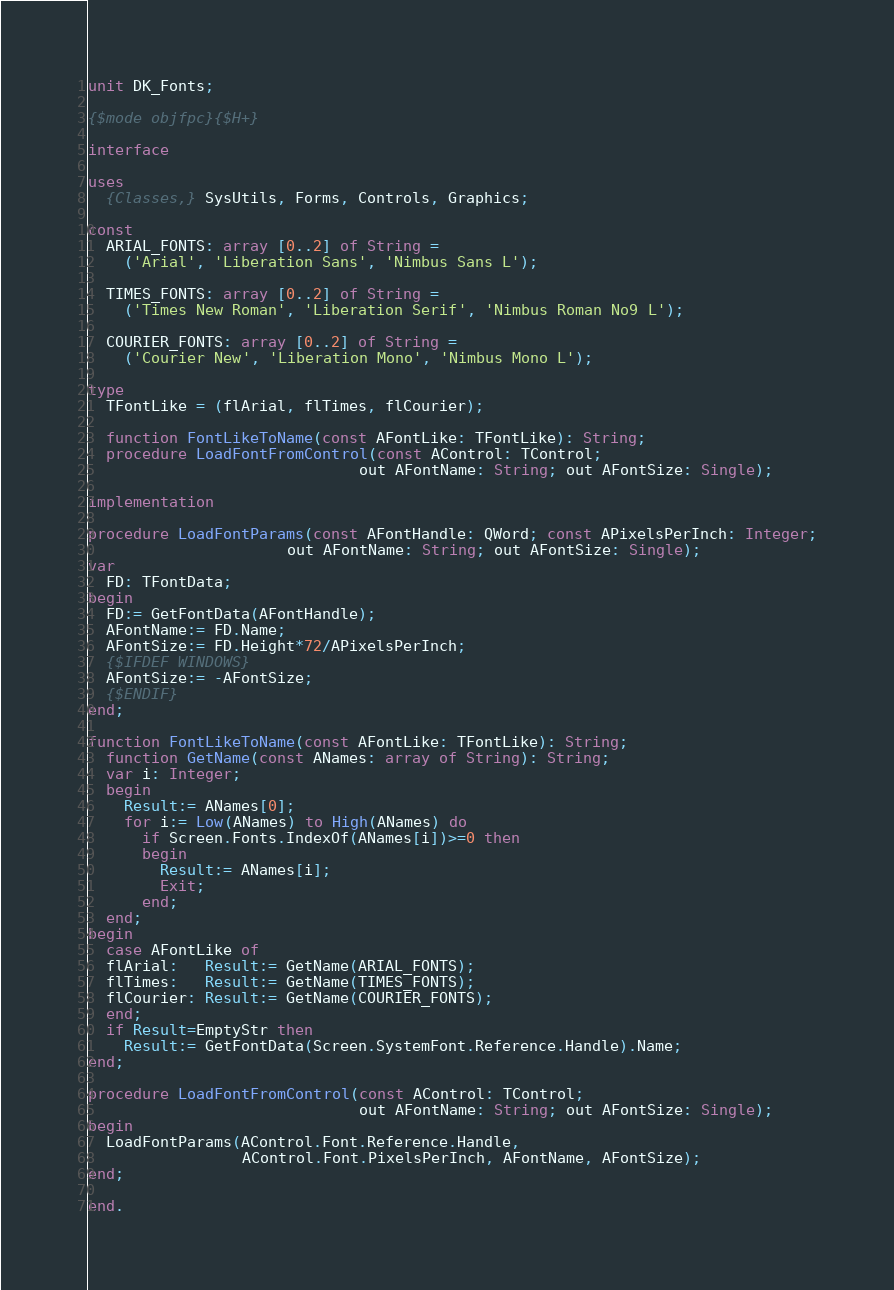Convert code to text. <code><loc_0><loc_0><loc_500><loc_500><_Pascal_>unit DK_Fonts;

{$mode objfpc}{$H+}

interface

uses
  {Classes,} SysUtils, Forms, Controls, Graphics;

const
  ARIAL_FONTS: array [0..2] of String =
    ('Arial', 'Liberation Sans', 'Nimbus Sans L');

  TIMES_FONTS: array [0..2] of String =
    ('Times New Roman', 'Liberation Serif', 'Nimbus Roman No9 L');

  COURIER_FONTS: array [0..2] of String =
    ('Courier New', 'Liberation Mono', 'Nimbus Mono L');

type
  TFontLike = (flArial, flTimes, flCourier);

  function FontLikeToName(const AFontLike: TFontLike): String;
  procedure LoadFontFromControl(const AControl: TControl;
                              out AFontName: String; out AFontSize: Single);

implementation

procedure LoadFontParams(const AFontHandle: QWord; const APixelsPerInch: Integer;
                      out AFontName: String; out AFontSize: Single);
var
  FD: TFontData;
begin
  FD:= GetFontData(AFontHandle);
  AFontName:= FD.Name;
  AFontSize:= FD.Height*72/APixelsPerInch;
  {$IFDEF WINDOWS}
  AFontSize:= -AFontSize;
  {$ENDIF}
end;

function FontLikeToName(const AFontLike: TFontLike): String;
  function GetName(const ANames: array of String): String;
  var i: Integer;
  begin
    Result:= ANames[0];
    for i:= Low(ANames) to High(ANames) do
      if Screen.Fonts.IndexOf(ANames[i])>=0 then
      begin
        Result:= ANames[i];
        Exit;
      end;
  end;
begin
  case AFontLike of
  flArial:   Result:= GetName(ARIAL_FONTS);
  flTimes:   Result:= GetName(TIMES_FONTS);
  flCourier: Result:= GetName(COURIER_FONTS);
  end;
  if Result=EmptyStr then
    Result:= GetFontData(Screen.SystemFont.Reference.Handle).Name;
end;

procedure LoadFontFromControl(const AControl: TControl;
                              out AFontName: String; out AFontSize: Single);
begin
  LoadFontParams(AControl.Font.Reference.Handle,
                 AControl.Font.PixelsPerInch, AFontName, AFontSize);
end;

end.

</code> 